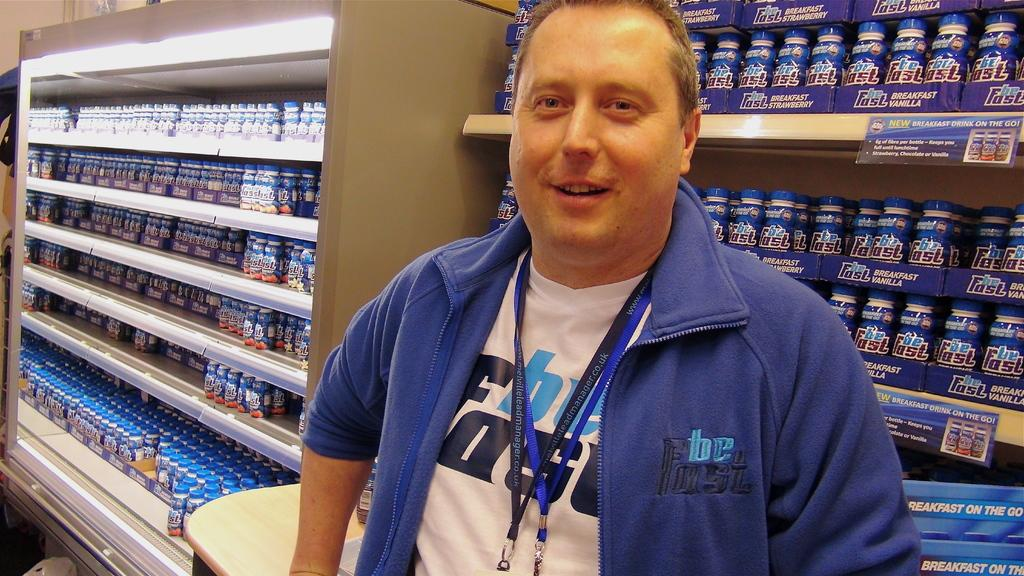What is the main subject of the image? There is a man standing in the center of the image. What can be seen in the background of the image? There are containers in the background of the image. What are the containers holding? The containers have bottles in them. What type of pot is being used for war in the image? There is no pot or war present in the image. Is there a van visible in the image? No, there is no van present in the image. 